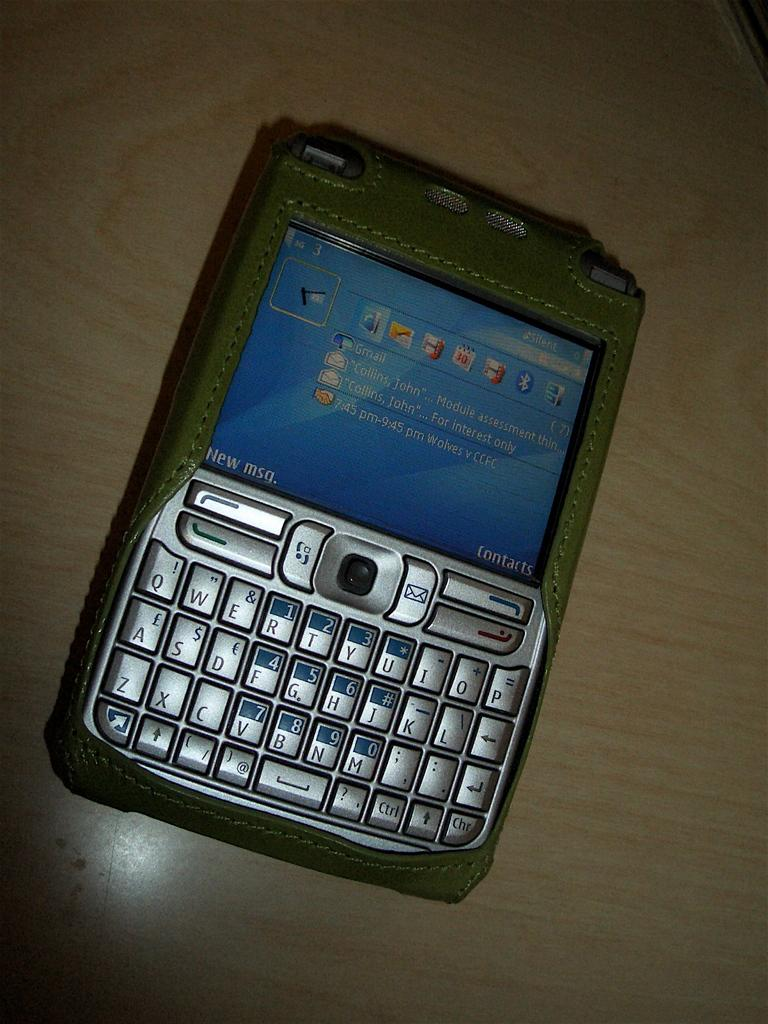<image>
Create a compact narrative representing the image presented. the name Collins is on the screen of the phone 